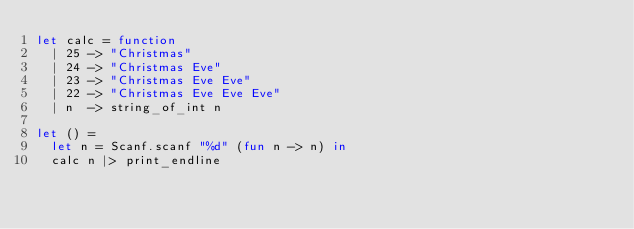<code> <loc_0><loc_0><loc_500><loc_500><_OCaml_>let calc = function
  | 25 -> "Christmas"
  | 24 -> "Christmas Eve"
  | 23 -> "Christmas Eve Eve"
  | 22 -> "Christmas Eve Eve Eve"
  | n  -> string_of_int n

let () =
  let n = Scanf.scanf "%d" (fun n -> n) in
  calc n |> print_endline

</code> 